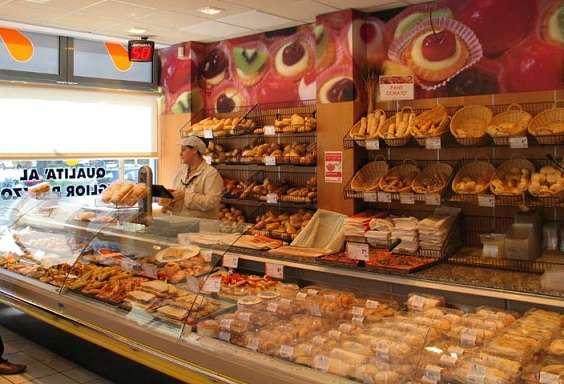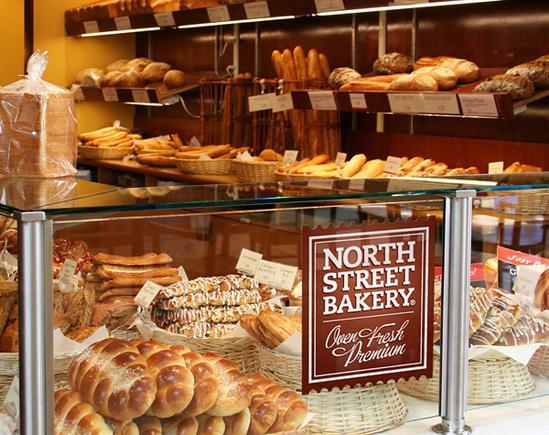The first image is the image on the left, the second image is the image on the right. Evaluate the accuracy of this statement regarding the images: "One female worker with a white top and no hat is behind a glass display case that turns a corner, in one image.". Is it true? Answer yes or no. No. The first image is the image on the left, the second image is the image on the right. For the images displayed, is the sentence "A sign announces the name of the bakery in the image on the right." factually correct? Answer yes or no. Yes. 